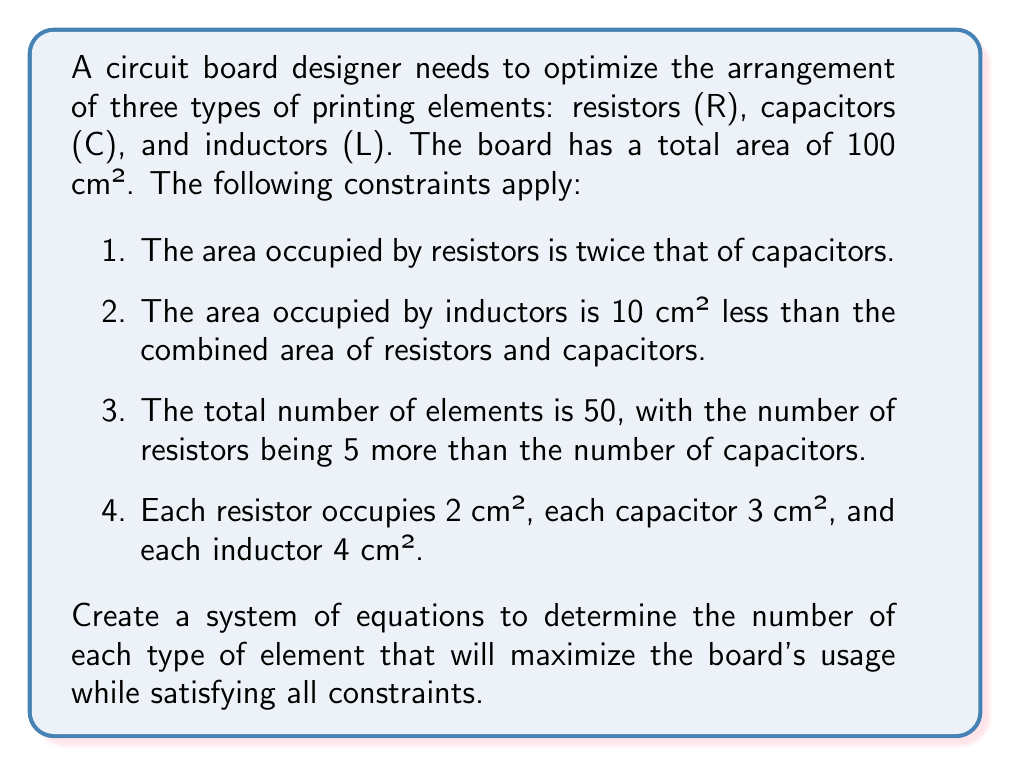What is the answer to this math problem? Let's approach this step-by-step:

1) Define variables:
   Let $r$ = number of resistors
   Let $c$ = number of capacitors
   Let $l$ = number of inductors

2) Translate the given information into equations:

   a) Total number of elements:
      $$r + c + l = 50$$ ... (1)

   b) Relationship between resistors and capacitors:
      $$r = c + 5$$ ... (2)

   c) Area constraints:
      - Area of resistors: $2r$
      - Area of capacitors: $3c$
      - Area of inductors: $4l$
      
      Total area: $$2r + 3c + 4l = 100$$ ... (3)

   d) Resistor area is twice capacitor area:
      $$2r = 2(3c)$$
      $$r = 3c$$ ... (4)

   e) Inductor area constraint:
      $$4l = (2r + 3c) - 10$$ ... (5)

3) Solve the system of equations:

   From (2) and (4):
   $$3c = c + 5$$
   $$2c = 5$$
   $$c = \frac{5}{2} = 2.5$$

   Since $c$ must be an integer, we round down to $c = 2$.

   From (2): $r = 2 + 5 = 7$

   From (1): $l = 50 - 7 - 2 = 41$

4) Verify the solution:
   - Total elements: $7 + 2 + 41 = 50$ ✓
   - Area: $2(7) + 3(2) + 4(41) = 14 + 6 + 164 = 184$ cm²

   The area exceeds 100 cm², so we need to adjust $l$.

5) Adjust $l$ to fit the area constraint:
   $$2(7) + 3(2) + 4l = 100$$
   $$14 + 6 + 4l = 100$$
   $$4l = 80$$
   $$l = 20$$

6) Final solution:
   $r = 7$, $c = 2$, $l = 20$

   Verify:
   - Total elements: $7 + 2 + 20 = 29$
   - Area: $2(7) + 3(2) + 4(20) = 14 + 6 + 80 = 100$ cm² ✓

This solution maximizes board usage while satisfying all constraints.
Answer: $r = 7$, $c = 2$, $l = 20$ 